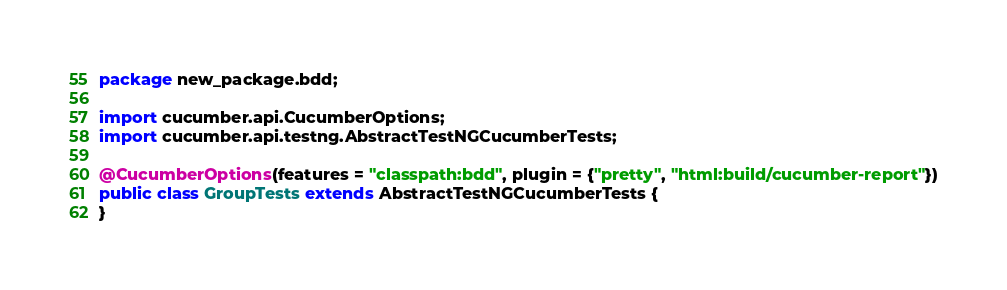Convert code to text. <code><loc_0><loc_0><loc_500><loc_500><_Java_>package new_package.bdd;

import cucumber.api.CucumberOptions;
import cucumber.api.testng.AbstractTestNGCucumberTests;

@CucumberOptions(features = "classpath:bdd", plugin = {"pretty", "html:build/cucumber-report"})
public class GroupTests extends AbstractTestNGCucumberTests {
}
</code> 